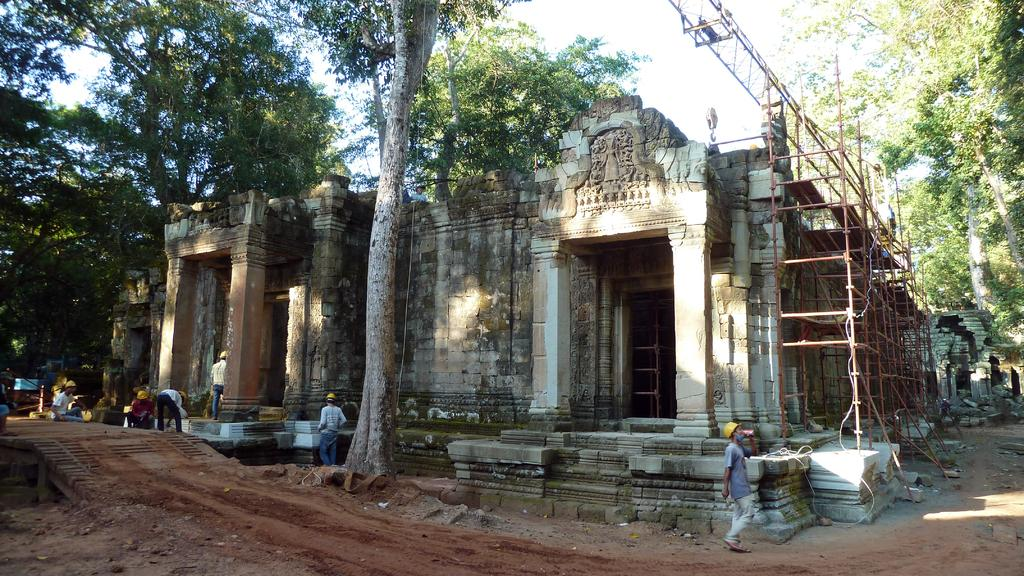What structure is present in the image? There is a building in the image. What objects can be seen near the building? There are rods in the image. Who is present near the building? There are people wearing helmets at the bottom of the image. What can be seen in the background of the image? There are trees and the sky visible in the background of the image. Can you tell me how many balloons are tied to the pocket of the person in the image? There is no person with a pocket or balloons present in the image. What type of creature is flying in the image? There is no creature flying in the image; only the building, rods, people wearing helmets, trees, and the sky are visible. 